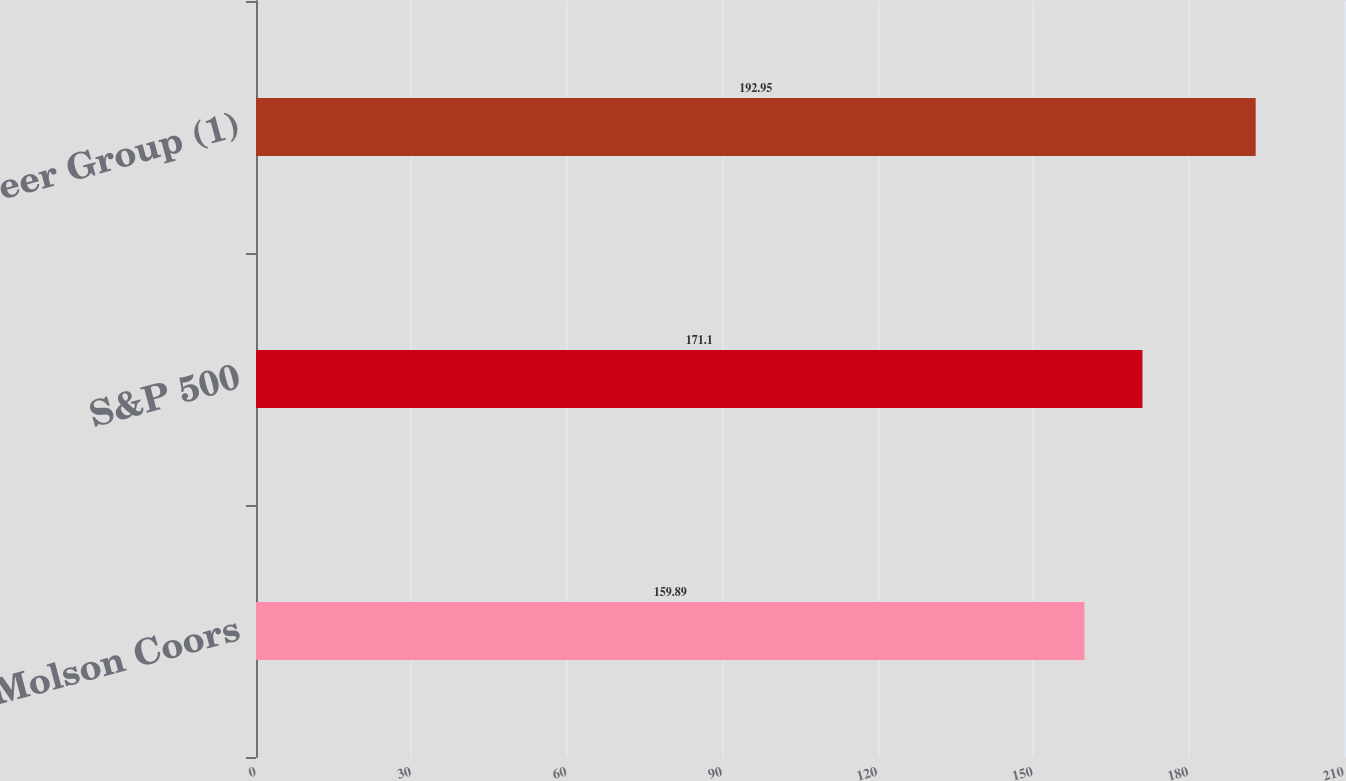Convert chart to OTSL. <chart><loc_0><loc_0><loc_500><loc_500><bar_chart><fcel>Molson Coors<fcel>S&P 500<fcel>Peer Group (1)<nl><fcel>159.89<fcel>171.1<fcel>192.95<nl></chart> 